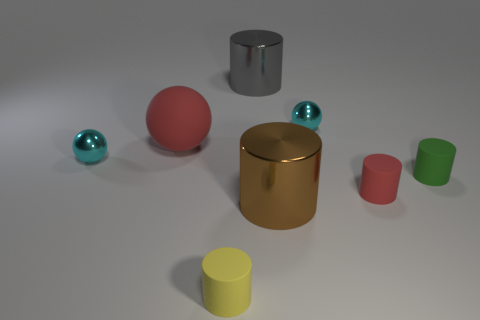Are there fewer things that are behind the big gray metal object than large rubber spheres behind the small yellow rubber thing?
Your response must be concise. Yes. How many things are cyan balls that are right of the big gray shiny object or red metal things?
Give a very brief answer. 1. What shape is the red thing that is left of the cylinder behind the tiny green cylinder?
Your answer should be compact. Sphere. Is there a gray metal cylinder that has the same size as the gray object?
Your answer should be compact. No. Is the number of brown matte blocks greater than the number of rubber cylinders?
Offer a terse response. No. There is a object right of the tiny red rubber object; is its size the same as the cyan metal sphere that is left of the gray shiny cylinder?
Your answer should be compact. Yes. What number of red things are both in front of the red ball and behind the red matte cylinder?
Provide a succinct answer. 0. There is another large object that is the same shape as the gray shiny object; what is its color?
Your answer should be compact. Brown. Are there fewer tiny cyan metallic balls than large balls?
Keep it short and to the point. No. Do the green thing and the red matte thing that is behind the tiny red rubber thing have the same size?
Your response must be concise. No. 